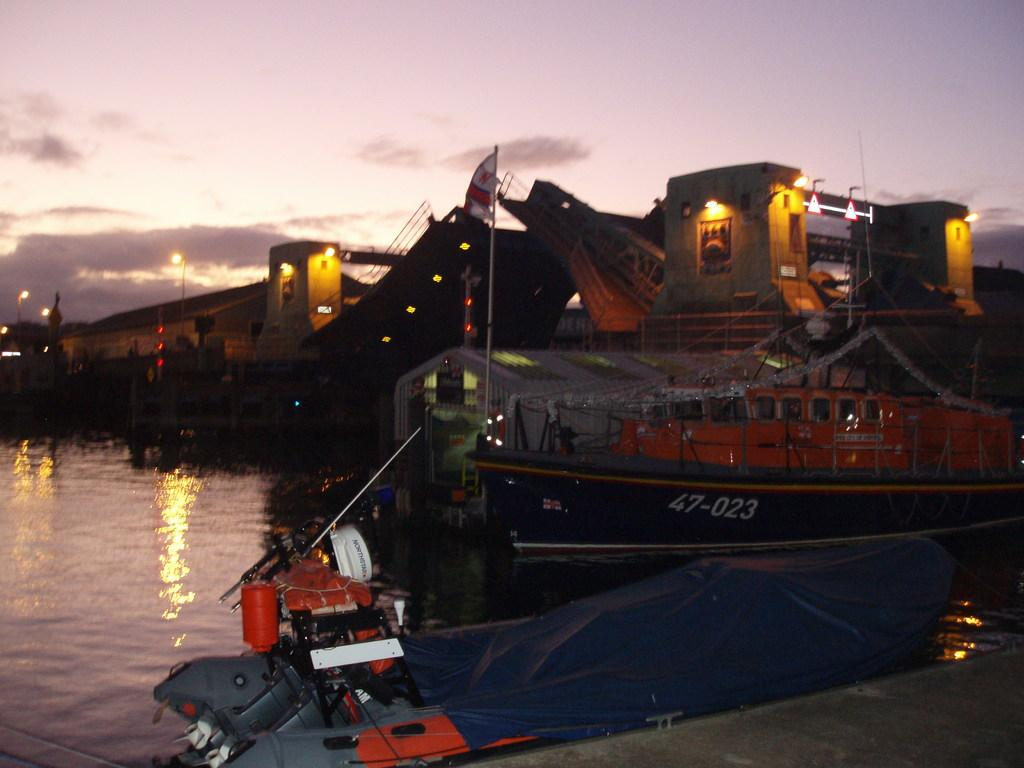How many boats are in the water in the image? There are two boats in the water in the image. What can be seen in the background of the image? There are buildings, lights, and other objects visible in the background of the image. Where is the goat located in the image? There is no goat present in the image. What type of animals can be seen in the zoo in the image? There is no zoo present in the image. 